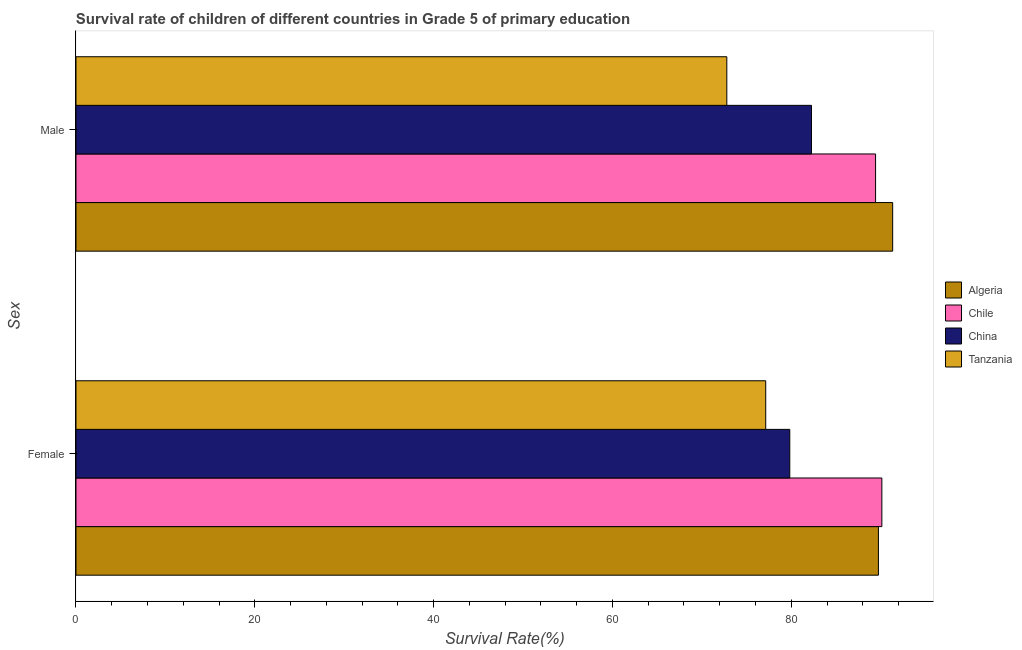How many groups of bars are there?
Your response must be concise. 2. Are the number of bars on each tick of the Y-axis equal?
Give a very brief answer. Yes. How many bars are there on the 2nd tick from the bottom?
Provide a succinct answer. 4. What is the survival rate of male students in primary education in Chile?
Offer a terse response. 89.43. Across all countries, what is the maximum survival rate of male students in primary education?
Give a very brief answer. 91.35. Across all countries, what is the minimum survival rate of male students in primary education?
Your response must be concise. 72.79. In which country was the survival rate of male students in primary education maximum?
Ensure brevity in your answer.  Algeria. In which country was the survival rate of female students in primary education minimum?
Provide a short and direct response. Tanzania. What is the total survival rate of female students in primary education in the graph?
Give a very brief answer. 336.87. What is the difference between the survival rate of male students in primary education in Chile and that in Algeria?
Your answer should be very brief. -1.91. What is the difference between the survival rate of male students in primary education in Tanzania and the survival rate of female students in primary education in Algeria?
Your answer should be compact. -16.96. What is the average survival rate of female students in primary education per country?
Make the answer very short. 84.22. What is the difference between the survival rate of male students in primary education and survival rate of female students in primary education in Tanzania?
Ensure brevity in your answer.  -4.35. What is the ratio of the survival rate of male students in primary education in Chile to that in China?
Offer a terse response. 1.09. In how many countries, is the survival rate of male students in primary education greater than the average survival rate of male students in primary education taken over all countries?
Keep it short and to the point. 2. What does the 1st bar from the bottom in Female represents?
Your response must be concise. Algeria. How many bars are there?
Provide a succinct answer. 8. Are all the bars in the graph horizontal?
Give a very brief answer. Yes. How many countries are there in the graph?
Give a very brief answer. 4. Are the values on the major ticks of X-axis written in scientific E-notation?
Offer a terse response. No. Where does the legend appear in the graph?
Offer a very short reply. Center right. How are the legend labels stacked?
Offer a very short reply. Vertical. What is the title of the graph?
Offer a terse response. Survival rate of children of different countries in Grade 5 of primary education. Does "Mauritius" appear as one of the legend labels in the graph?
Provide a short and direct response. No. What is the label or title of the X-axis?
Make the answer very short. Survival Rate(%). What is the label or title of the Y-axis?
Your answer should be very brief. Sex. What is the Survival Rate(%) in Algeria in Female?
Give a very brief answer. 89.75. What is the Survival Rate(%) of Chile in Female?
Your answer should be compact. 90.14. What is the Survival Rate(%) of China in Female?
Keep it short and to the point. 79.84. What is the Survival Rate(%) in Tanzania in Female?
Provide a succinct answer. 77.15. What is the Survival Rate(%) in Algeria in Male?
Keep it short and to the point. 91.35. What is the Survival Rate(%) of Chile in Male?
Ensure brevity in your answer.  89.43. What is the Survival Rate(%) in China in Male?
Your answer should be compact. 82.26. What is the Survival Rate(%) of Tanzania in Male?
Your answer should be compact. 72.79. Across all Sex, what is the maximum Survival Rate(%) of Algeria?
Offer a terse response. 91.35. Across all Sex, what is the maximum Survival Rate(%) of Chile?
Ensure brevity in your answer.  90.14. Across all Sex, what is the maximum Survival Rate(%) of China?
Provide a succinct answer. 82.26. Across all Sex, what is the maximum Survival Rate(%) of Tanzania?
Give a very brief answer. 77.15. Across all Sex, what is the minimum Survival Rate(%) of Algeria?
Offer a terse response. 89.75. Across all Sex, what is the minimum Survival Rate(%) of Chile?
Give a very brief answer. 89.43. Across all Sex, what is the minimum Survival Rate(%) in China?
Your response must be concise. 79.84. Across all Sex, what is the minimum Survival Rate(%) of Tanzania?
Make the answer very short. 72.79. What is the total Survival Rate(%) in Algeria in the graph?
Make the answer very short. 181.1. What is the total Survival Rate(%) in Chile in the graph?
Provide a short and direct response. 179.57. What is the total Survival Rate(%) in China in the graph?
Give a very brief answer. 162.1. What is the total Survival Rate(%) in Tanzania in the graph?
Ensure brevity in your answer.  149.94. What is the difference between the Survival Rate(%) in Algeria in Female and that in Male?
Make the answer very short. -1.59. What is the difference between the Survival Rate(%) in Chile in Female and that in Male?
Offer a terse response. 0.7. What is the difference between the Survival Rate(%) of China in Female and that in Male?
Offer a very short reply. -2.43. What is the difference between the Survival Rate(%) of Tanzania in Female and that in Male?
Your answer should be very brief. 4.35. What is the difference between the Survival Rate(%) in Algeria in Female and the Survival Rate(%) in Chile in Male?
Ensure brevity in your answer.  0.32. What is the difference between the Survival Rate(%) in Algeria in Female and the Survival Rate(%) in China in Male?
Ensure brevity in your answer.  7.49. What is the difference between the Survival Rate(%) in Algeria in Female and the Survival Rate(%) in Tanzania in Male?
Offer a very short reply. 16.96. What is the difference between the Survival Rate(%) in Chile in Female and the Survival Rate(%) in China in Male?
Your answer should be compact. 7.87. What is the difference between the Survival Rate(%) in Chile in Female and the Survival Rate(%) in Tanzania in Male?
Give a very brief answer. 17.34. What is the difference between the Survival Rate(%) in China in Female and the Survival Rate(%) in Tanzania in Male?
Ensure brevity in your answer.  7.04. What is the average Survival Rate(%) of Algeria per Sex?
Your answer should be very brief. 90.55. What is the average Survival Rate(%) of Chile per Sex?
Provide a succinct answer. 89.79. What is the average Survival Rate(%) in China per Sex?
Your answer should be compact. 81.05. What is the average Survival Rate(%) of Tanzania per Sex?
Your answer should be very brief. 74.97. What is the difference between the Survival Rate(%) in Algeria and Survival Rate(%) in Chile in Female?
Your answer should be very brief. -0.38. What is the difference between the Survival Rate(%) of Algeria and Survival Rate(%) of China in Female?
Ensure brevity in your answer.  9.91. What is the difference between the Survival Rate(%) of Algeria and Survival Rate(%) of Tanzania in Female?
Your response must be concise. 12.61. What is the difference between the Survival Rate(%) in Chile and Survival Rate(%) in China in Female?
Offer a very short reply. 10.3. What is the difference between the Survival Rate(%) in Chile and Survival Rate(%) in Tanzania in Female?
Make the answer very short. 12.99. What is the difference between the Survival Rate(%) of China and Survival Rate(%) of Tanzania in Female?
Your answer should be very brief. 2.69. What is the difference between the Survival Rate(%) in Algeria and Survival Rate(%) in Chile in Male?
Keep it short and to the point. 1.91. What is the difference between the Survival Rate(%) in Algeria and Survival Rate(%) in China in Male?
Provide a succinct answer. 9.08. What is the difference between the Survival Rate(%) of Algeria and Survival Rate(%) of Tanzania in Male?
Your response must be concise. 18.55. What is the difference between the Survival Rate(%) of Chile and Survival Rate(%) of China in Male?
Make the answer very short. 7.17. What is the difference between the Survival Rate(%) in Chile and Survival Rate(%) in Tanzania in Male?
Your response must be concise. 16.64. What is the difference between the Survival Rate(%) of China and Survival Rate(%) of Tanzania in Male?
Provide a succinct answer. 9.47. What is the ratio of the Survival Rate(%) of Algeria in Female to that in Male?
Your answer should be compact. 0.98. What is the ratio of the Survival Rate(%) in Chile in Female to that in Male?
Give a very brief answer. 1.01. What is the ratio of the Survival Rate(%) of China in Female to that in Male?
Offer a terse response. 0.97. What is the ratio of the Survival Rate(%) of Tanzania in Female to that in Male?
Make the answer very short. 1.06. What is the difference between the highest and the second highest Survival Rate(%) of Algeria?
Provide a short and direct response. 1.59. What is the difference between the highest and the second highest Survival Rate(%) of Chile?
Offer a terse response. 0.7. What is the difference between the highest and the second highest Survival Rate(%) in China?
Your response must be concise. 2.43. What is the difference between the highest and the second highest Survival Rate(%) of Tanzania?
Keep it short and to the point. 4.35. What is the difference between the highest and the lowest Survival Rate(%) in Algeria?
Give a very brief answer. 1.59. What is the difference between the highest and the lowest Survival Rate(%) in Chile?
Keep it short and to the point. 0.7. What is the difference between the highest and the lowest Survival Rate(%) of China?
Ensure brevity in your answer.  2.43. What is the difference between the highest and the lowest Survival Rate(%) of Tanzania?
Make the answer very short. 4.35. 